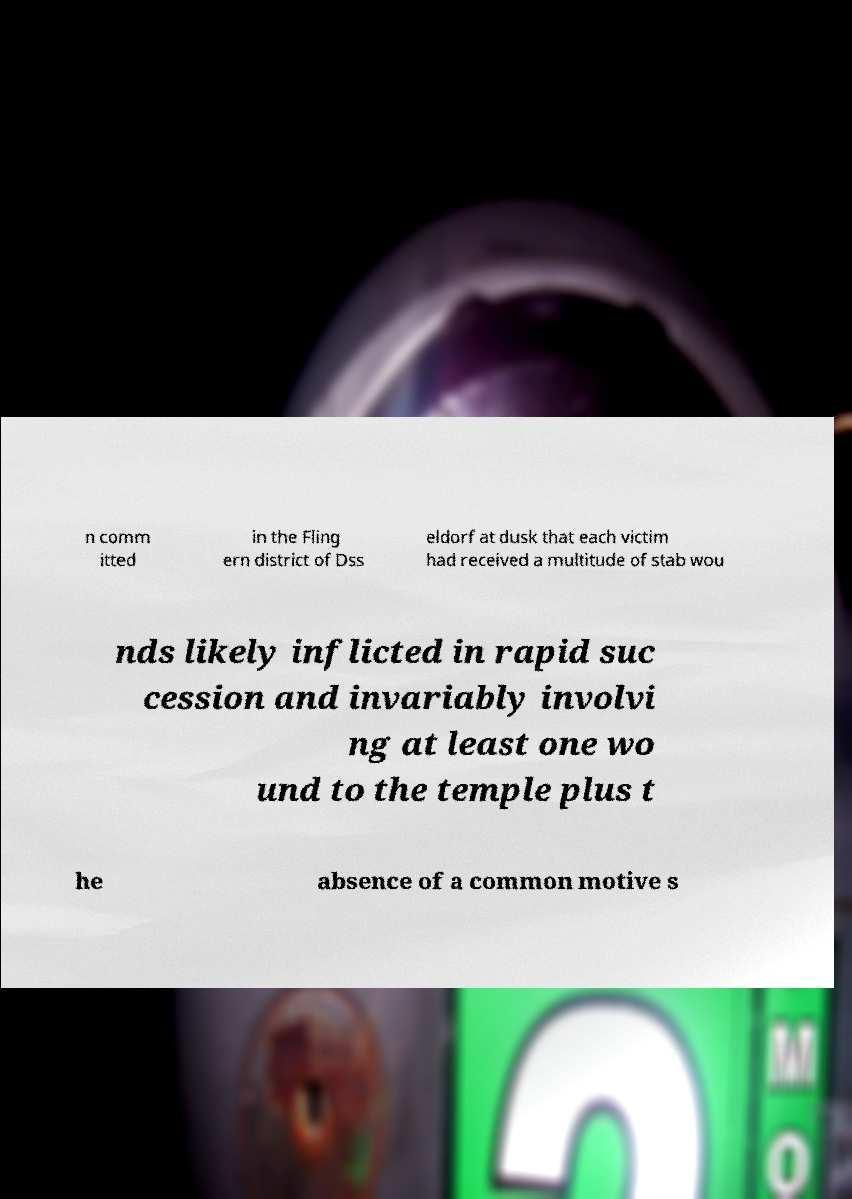Please read and relay the text visible in this image. What does it say? n comm itted in the Fling ern district of Dss eldorf at dusk that each victim had received a multitude of stab wou nds likely inflicted in rapid suc cession and invariably involvi ng at least one wo und to the temple plus t he absence of a common motive s 